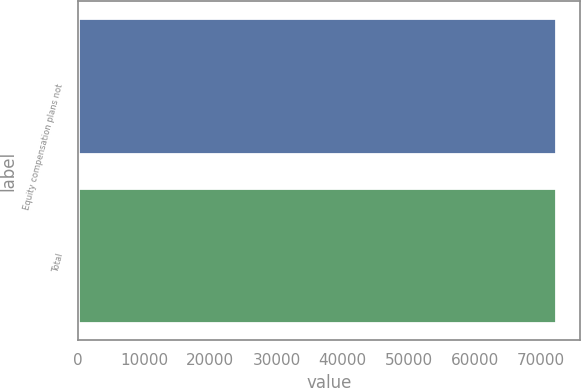Convert chart. <chart><loc_0><loc_0><loc_500><loc_500><bar_chart><fcel>Equity compensation plans not<fcel>Total<nl><fcel>72232<fcel>72232.1<nl></chart> 